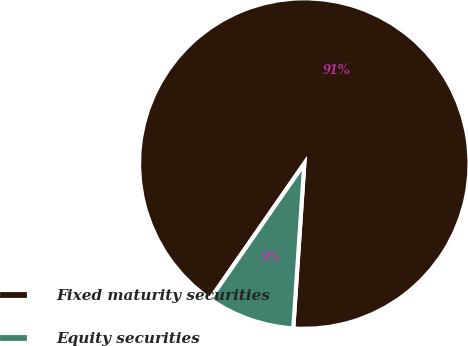Convert chart to OTSL. <chart><loc_0><loc_0><loc_500><loc_500><pie_chart><fcel>Fixed maturity securities<fcel>Equity securities<nl><fcel>91.4%<fcel>8.6%<nl></chart> 